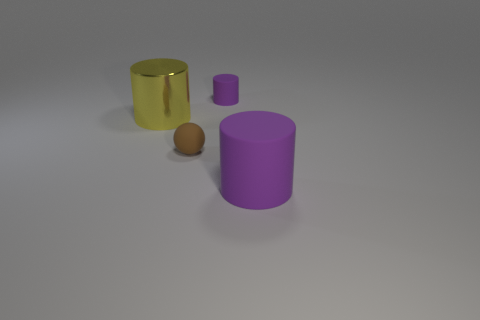There is a purple matte object on the left side of the big rubber object; does it have the same shape as the large thing behind the large purple cylinder?
Provide a short and direct response. Yes. What number of things are shiny things or small objects that are behind the brown matte object?
Provide a short and direct response. 2. How many other objects are there of the same shape as the large rubber thing?
Your answer should be very brief. 2. Are the cylinder behind the yellow shiny object and the tiny brown object made of the same material?
Offer a terse response. Yes. What number of things are either tiny things or big metallic cylinders?
Make the answer very short. 3. What is the size of the other yellow thing that is the same shape as the large rubber thing?
Keep it short and to the point. Large. The rubber ball is what size?
Keep it short and to the point. Small. Is the number of rubber spheres right of the large purple object greater than the number of brown metallic cubes?
Your answer should be compact. No. Are there any other things that have the same material as the large purple thing?
Your response must be concise. Yes. Is the color of the matte object behind the yellow shiny cylinder the same as the metallic cylinder to the left of the brown ball?
Ensure brevity in your answer.  No. 